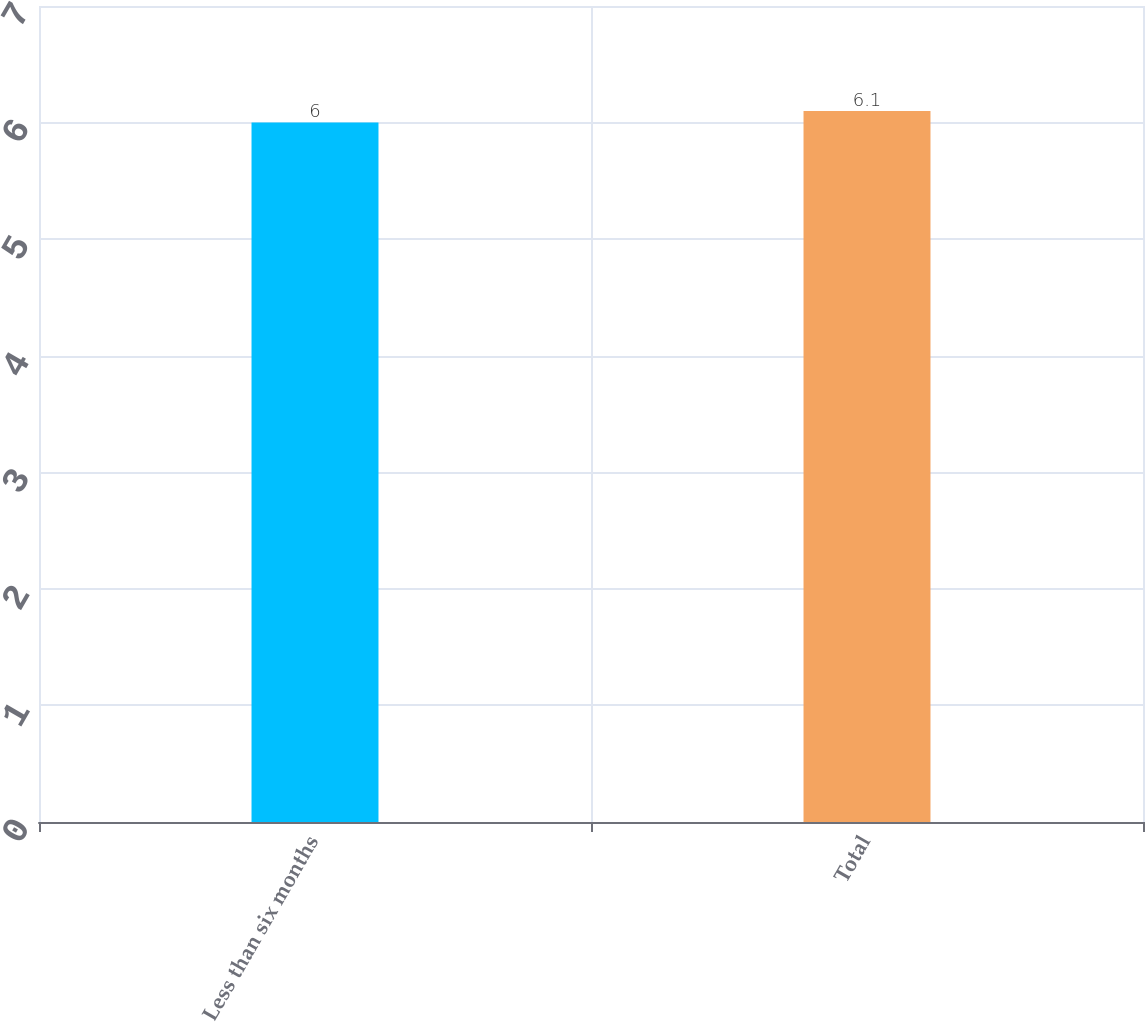Convert chart. <chart><loc_0><loc_0><loc_500><loc_500><bar_chart><fcel>Less than six months<fcel>Total<nl><fcel>6<fcel>6.1<nl></chart> 